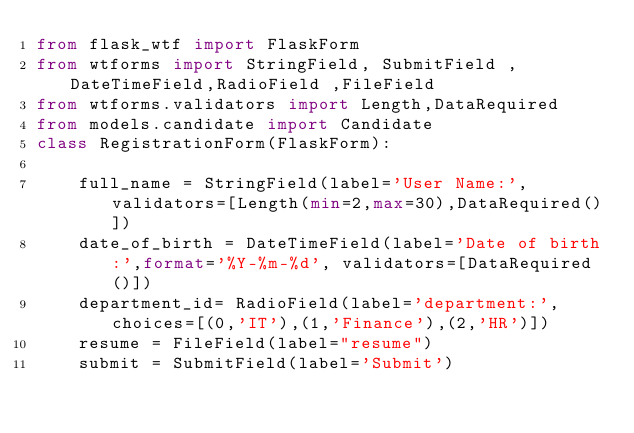Convert code to text. <code><loc_0><loc_0><loc_500><loc_500><_Python_>from flask_wtf import FlaskForm 
from wtforms import StringField, SubmitField , DateTimeField,RadioField ,FileField
from wtforms.validators import Length,DataRequired
from models.candidate import Candidate
class RegistrationForm(FlaskForm):

    full_name = StringField(label='User Name:',validators=[Length(min=2,max=30),DataRequired()])
    date_of_birth = DateTimeField(label='Date of birth:',format='%Y-%m-%d', validators=[DataRequired()])
    department_id= RadioField(label='department:', choices=[(0,'IT'),(1,'Finance'),(2,'HR')])
    resume = FileField(label="resume")
    submit = SubmitField(label='Submit')
</code> 